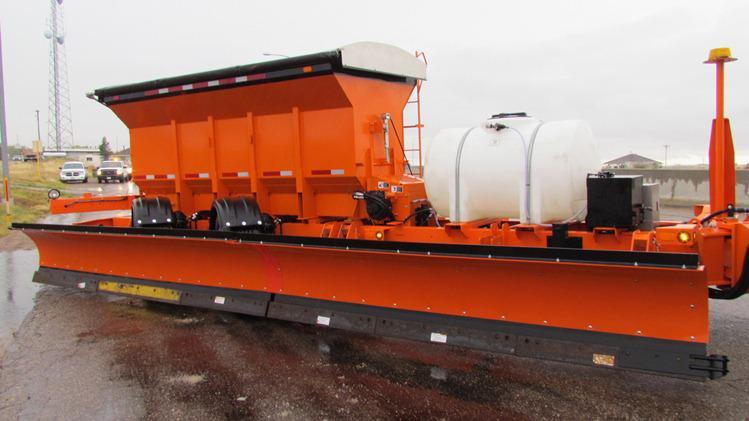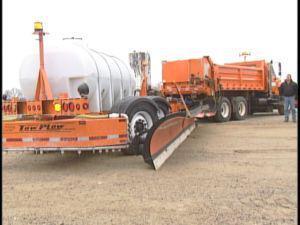The first image is the image on the left, the second image is the image on the right. Given the left and right images, does the statement "In one image the truck towing a second blade and salt bin has a yellow cab and gray body." hold true? Answer yes or no. No. 